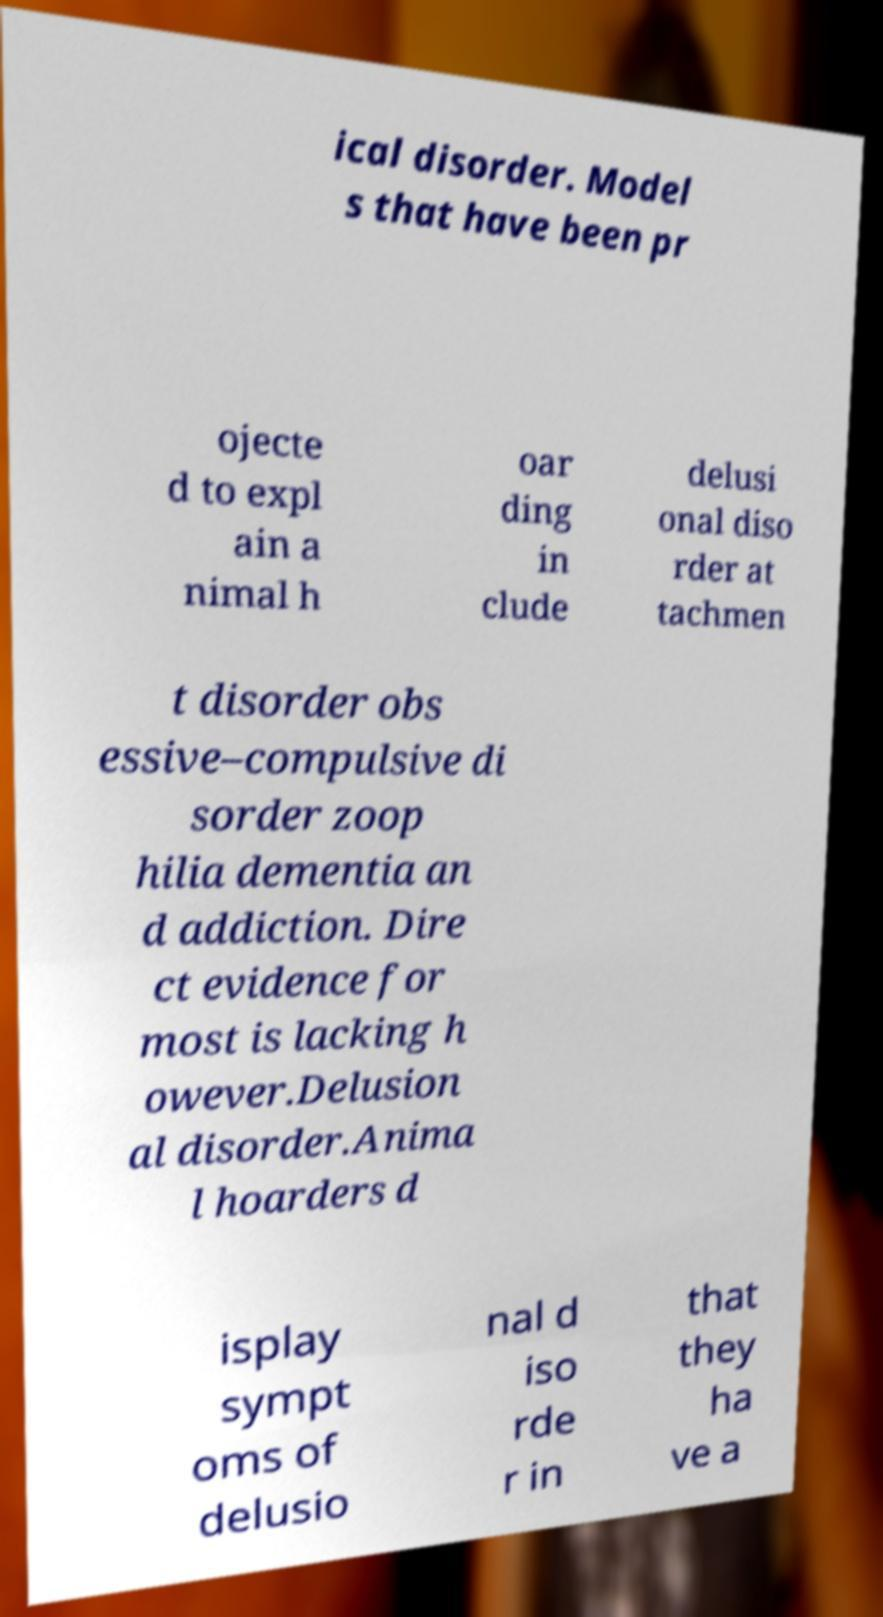What messages or text are displayed in this image? I need them in a readable, typed format. ical disorder. Model s that have been pr ojecte d to expl ain a nimal h oar ding in clude delusi onal diso rder at tachmen t disorder obs essive–compulsive di sorder zoop hilia dementia an d addiction. Dire ct evidence for most is lacking h owever.Delusion al disorder.Anima l hoarders d isplay sympt oms of delusio nal d iso rde r in that they ha ve a 